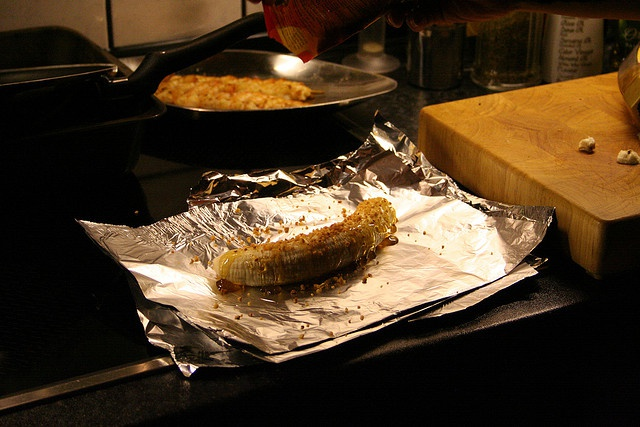Describe the objects in this image and their specific colors. I can see bowl in maroon, black, and red tones, banana in maroon, black, and olive tones, bottle in maroon, black, and brown tones, people in black and maroon tones, and bottle in maroon, black, and gray tones in this image. 